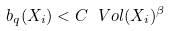Convert formula to latex. <formula><loc_0><loc_0><loc_500><loc_500>b _ { q } ( X _ { i } ) < C \ V o l ( X _ { i } ) ^ { \beta }</formula> 